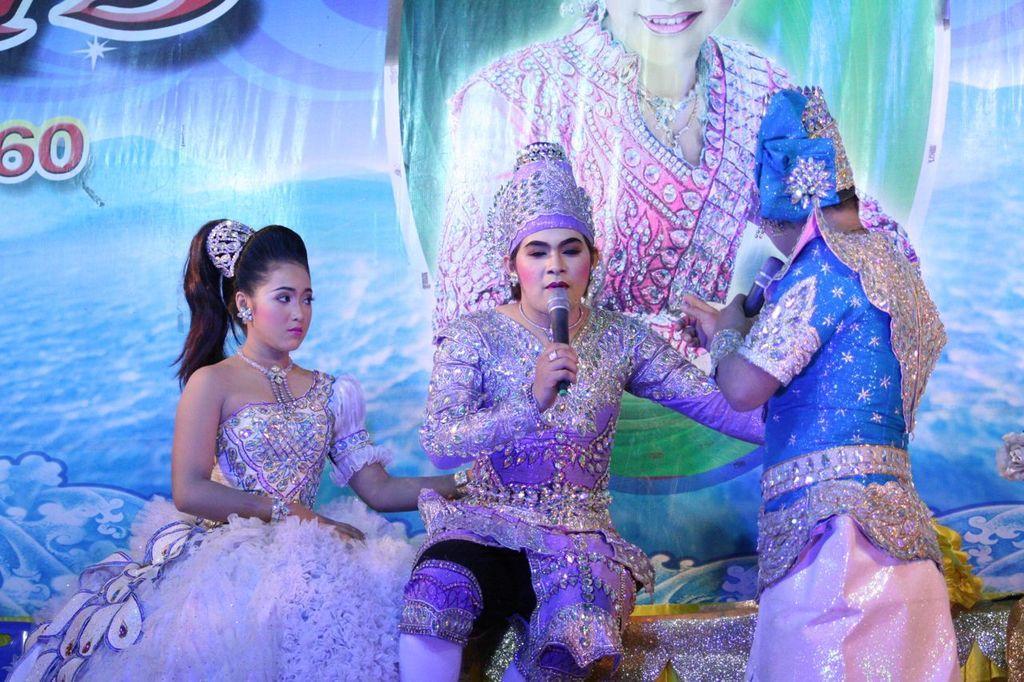In one or two sentences, can you explain what this image depicts? In this image we can see people in different costumes, microphones and in the background, we can see a banner with some text. 